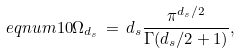Convert formula to latex. <formula><loc_0><loc_0><loc_500><loc_500>\ e q n u m { 1 0 } \Omega _ { d _ { s } } \, = \, d _ { s } \frac { \pi ^ { d _ { s } / 2 } } { \Gamma ( d _ { s } / 2 + 1 ) } ,</formula> 